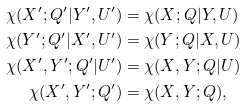<formula> <loc_0><loc_0><loc_500><loc_500>\chi ( X ^ { \prime } ; Q ^ { \prime } | Y ^ { \prime } , U ^ { \prime } ) & = \chi ( X ; Q | Y , U ) \\ \chi ( Y ^ { \prime } ; Q ^ { \prime } | X ^ { \prime } , U ^ { \prime } ) & = \chi ( Y ; Q | X , U ) \\ \chi ( X ^ { \prime } , Y ^ { \prime } ; Q ^ { \prime } | U ^ { \prime } ) & = \chi ( X , Y ; Q | U ) \\ \chi ( X ^ { \prime } , Y ^ { \prime } ; Q ^ { \prime } ) & = \chi ( X , Y ; Q ) ,</formula> 